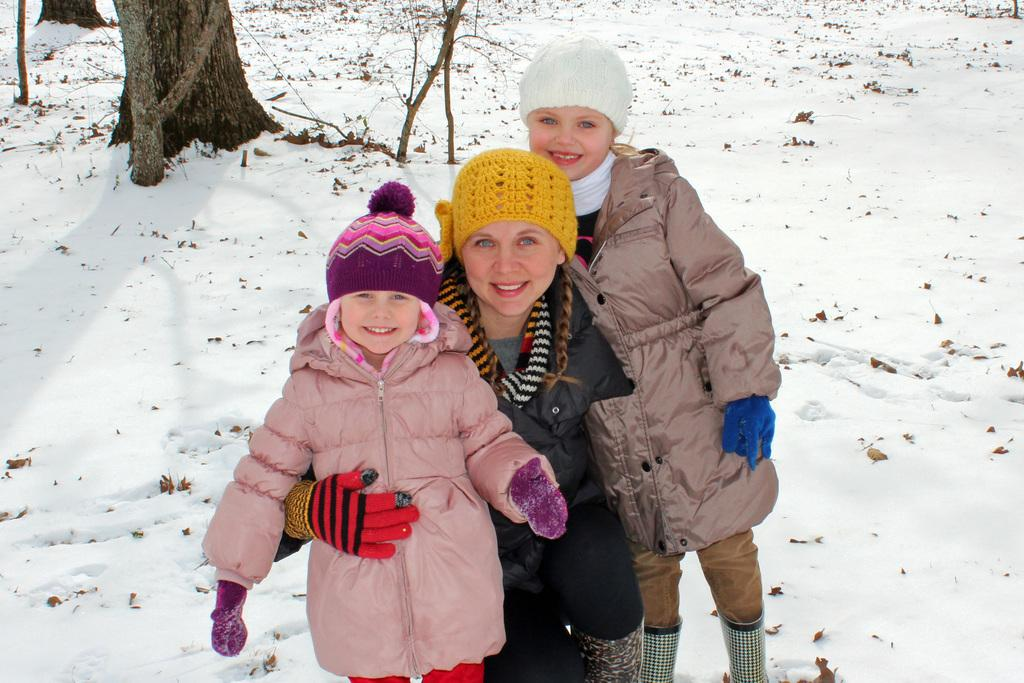How many people are present in the image? There are three people in the image. What is the terrain like in the image? The people are standing on snow. Can you describe the clothing of one of the individuals? A woman is wearing a yellow cap. What is the woman doing in the image? The woman is holding a child in her hand. What can be seen in the background of the image? There is a group of trees in the background of the image. What type of jam is being spread on the child's sandwich in the image? There is no sandwich or jam present in the image; it features three people standing on snow. Can you tell me the design of the locket the woman is wearing in the image? The woman is not wearing a locket in the image; she is wearing a yellow cap. 